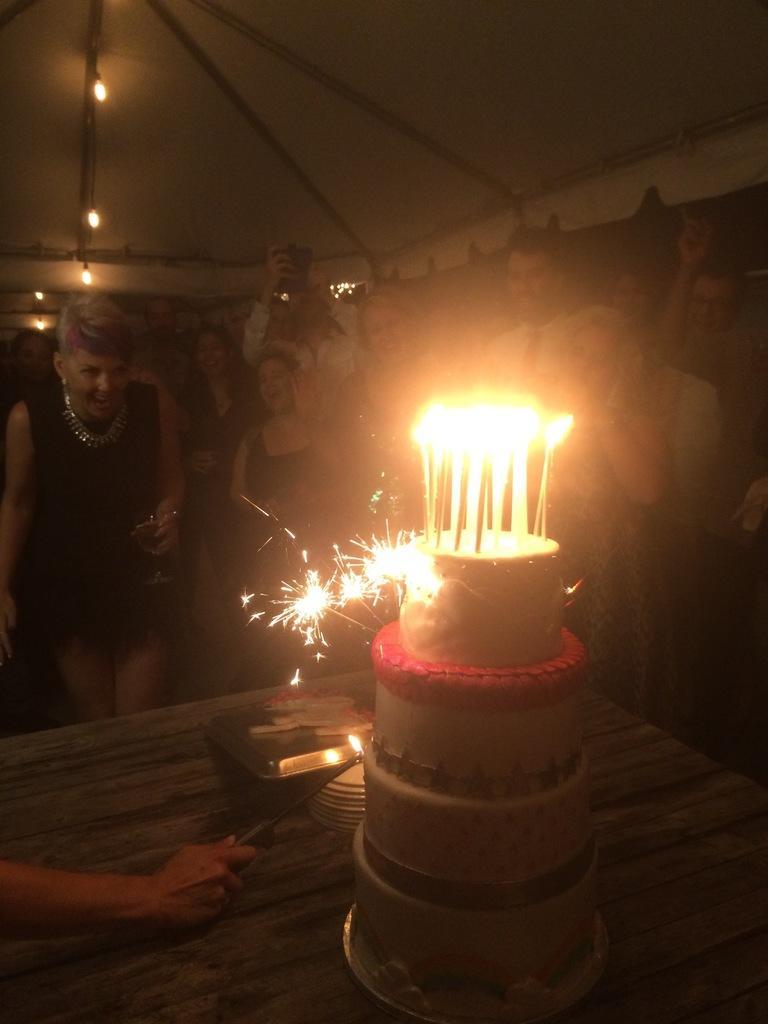Please provide a concise description of this image. In this image in front there is a table. On top of it there is a cake. On top of the cake there are candles. There are plates. There is a tray and we see a hand of a person holding the knife. Behind the table there are people. On top of the image there are lights. 